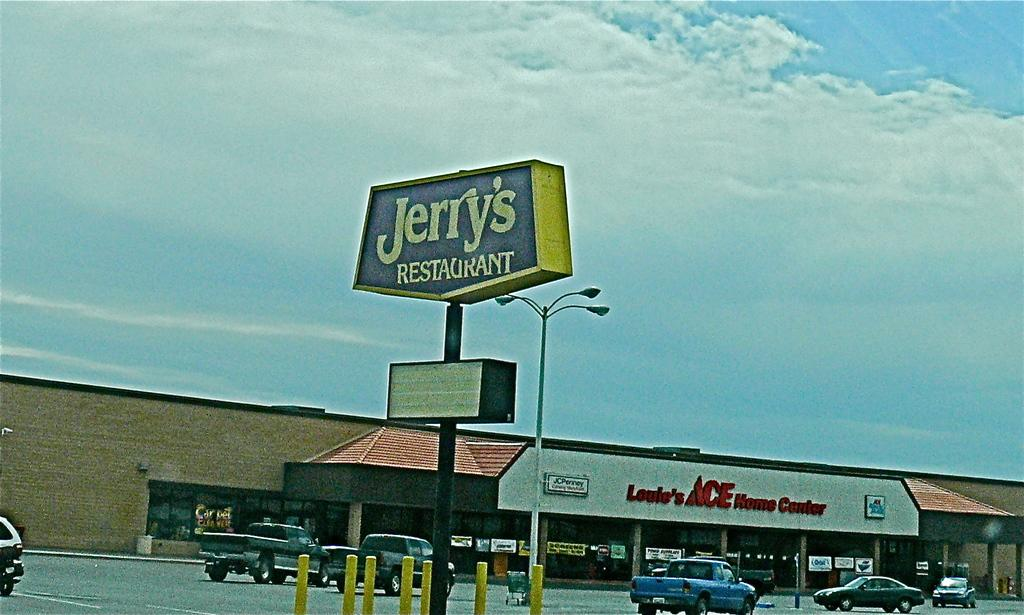<image>
Summarize the visual content of the image. Jerry's Restaurant is right next door to an ACE hardware store. 